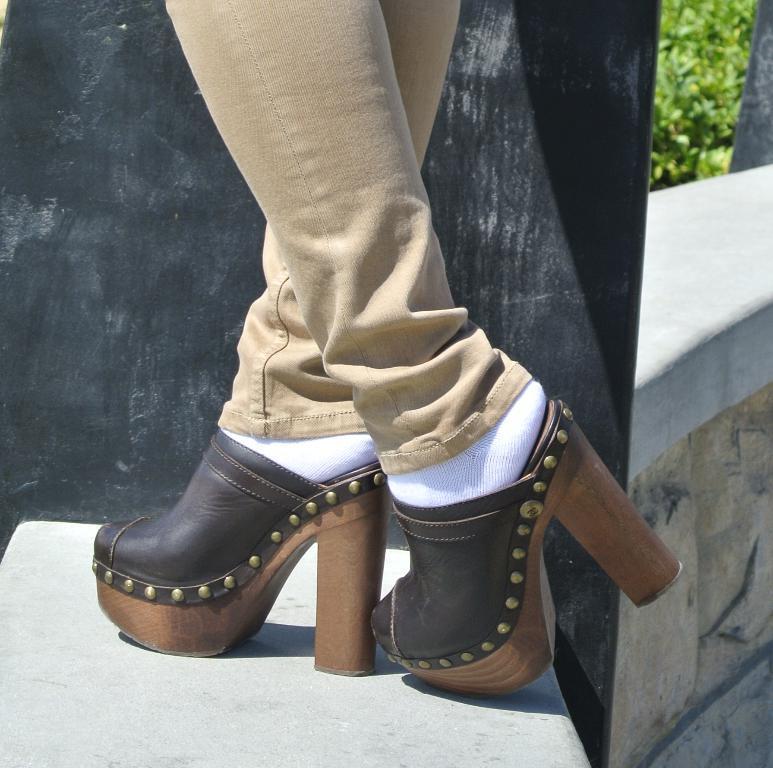How would you summarize this image in a sentence or two? In this image, we can see the legs of a person. We can see the ground. We can see a black colored object. We can also see some grass. 